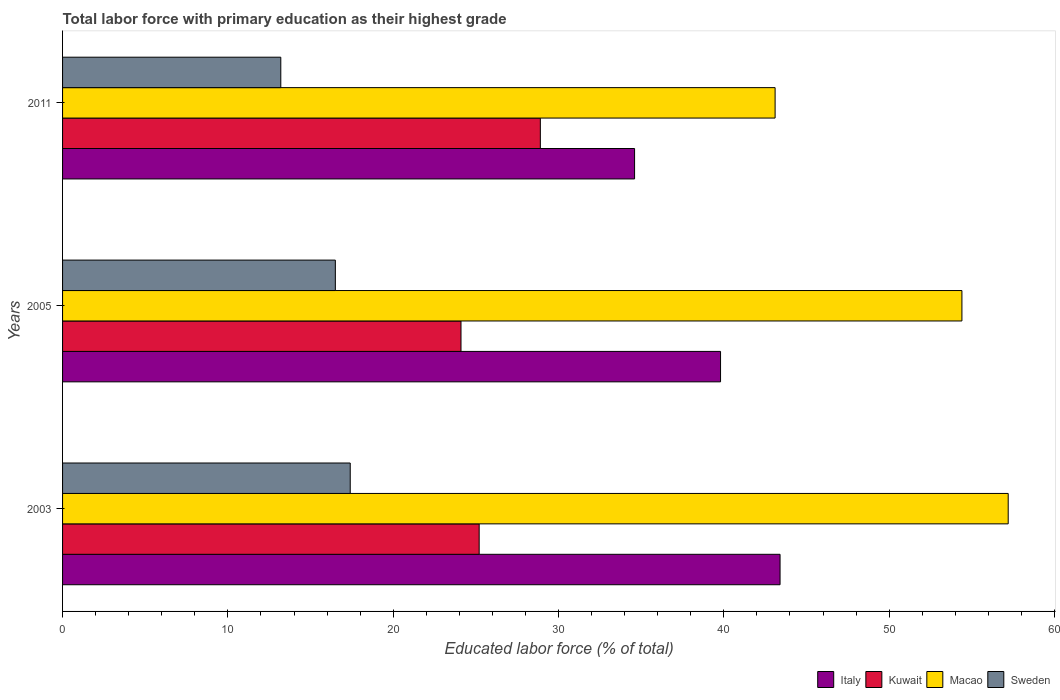How many different coloured bars are there?
Your answer should be compact. 4. How many groups of bars are there?
Your answer should be compact. 3. What is the label of the 1st group of bars from the top?
Make the answer very short. 2011. In how many cases, is the number of bars for a given year not equal to the number of legend labels?
Offer a very short reply. 0. What is the percentage of total labor force with primary education in Sweden in 2005?
Offer a very short reply. 16.5. Across all years, what is the maximum percentage of total labor force with primary education in Italy?
Provide a short and direct response. 43.4. Across all years, what is the minimum percentage of total labor force with primary education in Macao?
Keep it short and to the point. 43.1. What is the total percentage of total labor force with primary education in Kuwait in the graph?
Offer a very short reply. 78.2. What is the difference between the percentage of total labor force with primary education in Sweden in 2005 and that in 2011?
Your answer should be very brief. 3.3. What is the difference between the percentage of total labor force with primary education in Macao in 2011 and the percentage of total labor force with primary education in Kuwait in 2003?
Ensure brevity in your answer.  17.9. What is the average percentage of total labor force with primary education in Italy per year?
Keep it short and to the point. 39.27. In the year 2005, what is the difference between the percentage of total labor force with primary education in Sweden and percentage of total labor force with primary education in Macao?
Keep it short and to the point. -37.9. What is the ratio of the percentage of total labor force with primary education in Sweden in 2003 to that in 2011?
Offer a terse response. 1.32. What is the difference between the highest and the second highest percentage of total labor force with primary education in Kuwait?
Your response must be concise. 3.7. What is the difference between the highest and the lowest percentage of total labor force with primary education in Sweden?
Make the answer very short. 4.2. Is it the case that in every year, the sum of the percentage of total labor force with primary education in Sweden and percentage of total labor force with primary education in Kuwait is greater than the sum of percentage of total labor force with primary education in Macao and percentage of total labor force with primary education in Italy?
Offer a terse response. No. What does the 3rd bar from the top in 2011 represents?
Your answer should be very brief. Kuwait. What does the 3rd bar from the bottom in 2005 represents?
Your answer should be compact. Macao. How many bars are there?
Provide a short and direct response. 12. Are all the bars in the graph horizontal?
Provide a short and direct response. Yes. Does the graph contain grids?
Keep it short and to the point. No. What is the title of the graph?
Provide a succinct answer. Total labor force with primary education as their highest grade. What is the label or title of the X-axis?
Offer a terse response. Educated labor force (% of total). What is the label or title of the Y-axis?
Your answer should be compact. Years. What is the Educated labor force (% of total) of Italy in 2003?
Your response must be concise. 43.4. What is the Educated labor force (% of total) in Kuwait in 2003?
Your answer should be compact. 25.2. What is the Educated labor force (% of total) of Macao in 2003?
Provide a succinct answer. 57.2. What is the Educated labor force (% of total) in Sweden in 2003?
Ensure brevity in your answer.  17.4. What is the Educated labor force (% of total) of Italy in 2005?
Ensure brevity in your answer.  39.8. What is the Educated labor force (% of total) in Kuwait in 2005?
Make the answer very short. 24.1. What is the Educated labor force (% of total) in Macao in 2005?
Keep it short and to the point. 54.4. What is the Educated labor force (% of total) in Italy in 2011?
Offer a terse response. 34.6. What is the Educated labor force (% of total) of Kuwait in 2011?
Give a very brief answer. 28.9. What is the Educated labor force (% of total) in Macao in 2011?
Your answer should be very brief. 43.1. What is the Educated labor force (% of total) of Sweden in 2011?
Offer a very short reply. 13.2. Across all years, what is the maximum Educated labor force (% of total) of Italy?
Offer a terse response. 43.4. Across all years, what is the maximum Educated labor force (% of total) in Kuwait?
Provide a succinct answer. 28.9. Across all years, what is the maximum Educated labor force (% of total) of Macao?
Ensure brevity in your answer.  57.2. Across all years, what is the maximum Educated labor force (% of total) of Sweden?
Give a very brief answer. 17.4. Across all years, what is the minimum Educated labor force (% of total) of Italy?
Your response must be concise. 34.6. Across all years, what is the minimum Educated labor force (% of total) in Kuwait?
Offer a terse response. 24.1. Across all years, what is the minimum Educated labor force (% of total) of Macao?
Ensure brevity in your answer.  43.1. Across all years, what is the minimum Educated labor force (% of total) in Sweden?
Ensure brevity in your answer.  13.2. What is the total Educated labor force (% of total) in Italy in the graph?
Offer a terse response. 117.8. What is the total Educated labor force (% of total) of Kuwait in the graph?
Offer a very short reply. 78.2. What is the total Educated labor force (% of total) in Macao in the graph?
Your answer should be compact. 154.7. What is the total Educated labor force (% of total) in Sweden in the graph?
Keep it short and to the point. 47.1. What is the difference between the Educated labor force (% of total) of Kuwait in 2003 and that in 2005?
Give a very brief answer. 1.1. What is the difference between the Educated labor force (% of total) in Macao in 2003 and that in 2005?
Give a very brief answer. 2.8. What is the difference between the Educated labor force (% of total) of Kuwait in 2003 and that in 2011?
Provide a short and direct response. -3.7. What is the difference between the Educated labor force (% of total) of Sweden in 2003 and that in 2011?
Offer a terse response. 4.2. What is the difference between the Educated labor force (% of total) in Kuwait in 2005 and that in 2011?
Offer a very short reply. -4.8. What is the difference between the Educated labor force (% of total) of Italy in 2003 and the Educated labor force (% of total) of Kuwait in 2005?
Your answer should be very brief. 19.3. What is the difference between the Educated labor force (% of total) in Italy in 2003 and the Educated labor force (% of total) in Sweden in 2005?
Your answer should be very brief. 26.9. What is the difference between the Educated labor force (% of total) of Kuwait in 2003 and the Educated labor force (% of total) of Macao in 2005?
Offer a very short reply. -29.2. What is the difference between the Educated labor force (% of total) of Macao in 2003 and the Educated labor force (% of total) of Sweden in 2005?
Your answer should be compact. 40.7. What is the difference between the Educated labor force (% of total) in Italy in 2003 and the Educated labor force (% of total) in Macao in 2011?
Provide a short and direct response. 0.3. What is the difference between the Educated labor force (% of total) in Italy in 2003 and the Educated labor force (% of total) in Sweden in 2011?
Give a very brief answer. 30.2. What is the difference between the Educated labor force (% of total) of Kuwait in 2003 and the Educated labor force (% of total) of Macao in 2011?
Your answer should be very brief. -17.9. What is the difference between the Educated labor force (% of total) in Italy in 2005 and the Educated labor force (% of total) in Sweden in 2011?
Ensure brevity in your answer.  26.6. What is the difference between the Educated labor force (% of total) of Kuwait in 2005 and the Educated labor force (% of total) of Macao in 2011?
Offer a very short reply. -19. What is the difference between the Educated labor force (% of total) in Kuwait in 2005 and the Educated labor force (% of total) in Sweden in 2011?
Make the answer very short. 10.9. What is the difference between the Educated labor force (% of total) in Macao in 2005 and the Educated labor force (% of total) in Sweden in 2011?
Ensure brevity in your answer.  41.2. What is the average Educated labor force (% of total) of Italy per year?
Make the answer very short. 39.27. What is the average Educated labor force (% of total) in Kuwait per year?
Your answer should be compact. 26.07. What is the average Educated labor force (% of total) of Macao per year?
Offer a very short reply. 51.57. What is the average Educated labor force (% of total) of Sweden per year?
Give a very brief answer. 15.7. In the year 2003, what is the difference between the Educated labor force (% of total) of Italy and Educated labor force (% of total) of Kuwait?
Give a very brief answer. 18.2. In the year 2003, what is the difference between the Educated labor force (% of total) of Italy and Educated labor force (% of total) of Macao?
Offer a terse response. -13.8. In the year 2003, what is the difference between the Educated labor force (% of total) of Italy and Educated labor force (% of total) of Sweden?
Keep it short and to the point. 26. In the year 2003, what is the difference between the Educated labor force (% of total) in Kuwait and Educated labor force (% of total) in Macao?
Your answer should be compact. -32. In the year 2003, what is the difference between the Educated labor force (% of total) in Macao and Educated labor force (% of total) in Sweden?
Provide a succinct answer. 39.8. In the year 2005, what is the difference between the Educated labor force (% of total) of Italy and Educated labor force (% of total) of Kuwait?
Offer a very short reply. 15.7. In the year 2005, what is the difference between the Educated labor force (% of total) in Italy and Educated labor force (% of total) in Macao?
Offer a very short reply. -14.6. In the year 2005, what is the difference between the Educated labor force (% of total) of Italy and Educated labor force (% of total) of Sweden?
Keep it short and to the point. 23.3. In the year 2005, what is the difference between the Educated labor force (% of total) of Kuwait and Educated labor force (% of total) of Macao?
Keep it short and to the point. -30.3. In the year 2005, what is the difference between the Educated labor force (% of total) in Kuwait and Educated labor force (% of total) in Sweden?
Offer a terse response. 7.6. In the year 2005, what is the difference between the Educated labor force (% of total) in Macao and Educated labor force (% of total) in Sweden?
Keep it short and to the point. 37.9. In the year 2011, what is the difference between the Educated labor force (% of total) of Italy and Educated labor force (% of total) of Kuwait?
Give a very brief answer. 5.7. In the year 2011, what is the difference between the Educated labor force (% of total) in Italy and Educated labor force (% of total) in Macao?
Offer a very short reply. -8.5. In the year 2011, what is the difference between the Educated labor force (% of total) of Italy and Educated labor force (% of total) of Sweden?
Offer a terse response. 21.4. In the year 2011, what is the difference between the Educated labor force (% of total) in Macao and Educated labor force (% of total) in Sweden?
Your answer should be very brief. 29.9. What is the ratio of the Educated labor force (% of total) in Italy in 2003 to that in 2005?
Your answer should be very brief. 1.09. What is the ratio of the Educated labor force (% of total) in Kuwait in 2003 to that in 2005?
Your answer should be compact. 1.05. What is the ratio of the Educated labor force (% of total) in Macao in 2003 to that in 2005?
Provide a short and direct response. 1.05. What is the ratio of the Educated labor force (% of total) in Sweden in 2003 to that in 2005?
Make the answer very short. 1.05. What is the ratio of the Educated labor force (% of total) in Italy in 2003 to that in 2011?
Your answer should be compact. 1.25. What is the ratio of the Educated labor force (% of total) in Kuwait in 2003 to that in 2011?
Your response must be concise. 0.87. What is the ratio of the Educated labor force (% of total) in Macao in 2003 to that in 2011?
Your answer should be compact. 1.33. What is the ratio of the Educated labor force (% of total) in Sweden in 2003 to that in 2011?
Give a very brief answer. 1.32. What is the ratio of the Educated labor force (% of total) in Italy in 2005 to that in 2011?
Your answer should be compact. 1.15. What is the ratio of the Educated labor force (% of total) in Kuwait in 2005 to that in 2011?
Keep it short and to the point. 0.83. What is the ratio of the Educated labor force (% of total) in Macao in 2005 to that in 2011?
Your response must be concise. 1.26. What is the difference between the highest and the second highest Educated labor force (% of total) of Italy?
Your answer should be very brief. 3.6. What is the difference between the highest and the second highest Educated labor force (% of total) of Kuwait?
Keep it short and to the point. 3.7. What is the difference between the highest and the second highest Educated labor force (% of total) in Macao?
Provide a short and direct response. 2.8. 